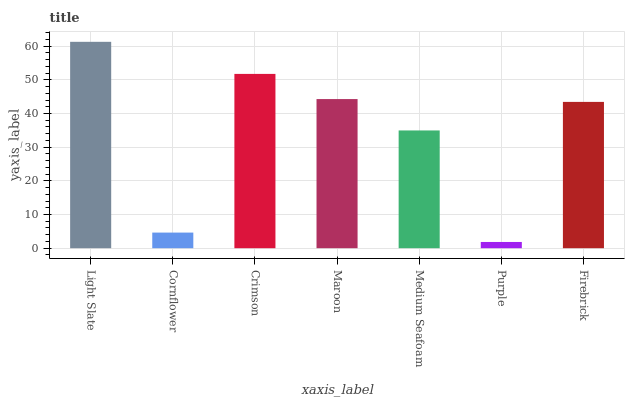Is Purple the minimum?
Answer yes or no. Yes. Is Light Slate the maximum?
Answer yes or no. Yes. Is Cornflower the minimum?
Answer yes or no. No. Is Cornflower the maximum?
Answer yes or no. No. Is Light Slate greater than Cornflower?
Answer yes or no. Yes. Is Cornflower less than Light Slate?
Answer yes or no. Yes. Is Cornflower greater than Light Slate?
Answer yes or no. No. Is Light Slate less than Cornflower?
Answer yes or no. No. Is Firebrick the high median?
Answer yes or no. Yes. Is Firebrick the low median?
Answer yes or no. Yes. Is Medium Seafoam the high median?
Answer yes or no. No. Is Crimson the low median?
Answer yes or no. No. 